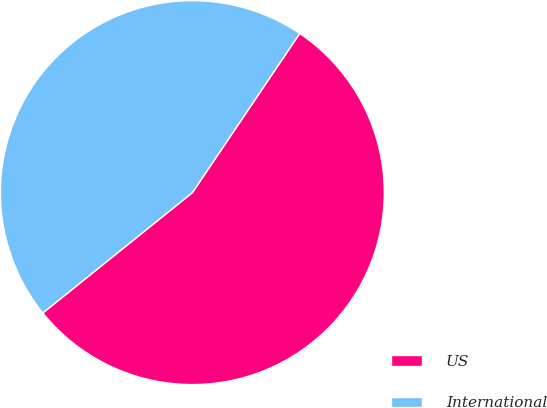<chart> <loc_0><loc_0><loc_500><loc_500><pie_chart><fcel>US<fcel>International<nl><fcel>54.77%<fcel>45.23%<nl></chart> 